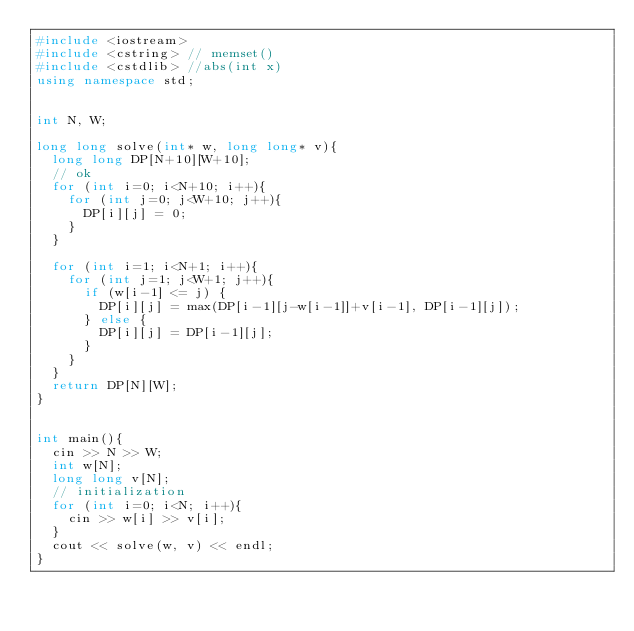<code> <loc_0><loc_0><loc_500><loc_500><_C++_>#include <iostream>
#include <cstring> // memset()
#include <cstdlib> //abs(int x)
using namespace std;


int N, W;

long long solve(int* w, long long* v){
  long long DP[N+10][W+10];
  // ok
  for (int i=0; i<N+10; i++){
    for (int j=0; j<W+10; j++){
      DP[i][j] = 0;
    }
  }

  for (int i=1; i<N+1; i++){
    for (int j=1; j<W+1; j++){
      if (w[i-1] <= j) {
        DP[i][j] = max(DP[i-1][j-w[i-1]]+v[i-1], DP[i-1][j]);
      } else {
        DP[i][j] = DP[i-1][j];
      }
    }
  }
  return DP[N][W];
}


int main(){
  cin >> N >> W;
  int w[N];
  long long v[N];
  // initialization
  for (int i=0; i<N; i++){
    cin >> w[i] >> v[i];
  }
  cout << solve(w, v) << endl;
}
</code> 